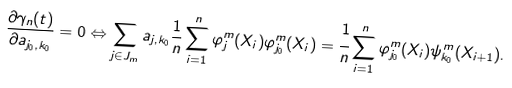<formula> <loc_0><loc_0><loc_500><loc_500>\frac { \partial \gamma _ { n } ( t ) } { \partial { a } _ { j _ { 0 } , k _ { 0 } } } = 0 \Leftrightarrow \sum _ { j \in J _ { m } } { a } _ { j , k _ { 0 } } \frac { 1 } { n } \sum _ { i = 1 } ^ { n } \varphi _ { j } ^ { m } ( X _ { i } ) \varphi _ { j _ { 0 } } ^ { m } ( X _ { i } ) = \cfrac { 1 } { n } \sum _ { i = 1 } ^ { n } \varphi _ { j _ { 0 } } ^ { m } ( X _ { i } ) \psi _ { k _ { 0 } } ^ { m } ( X _ { i + 1 } ) .</formula> 